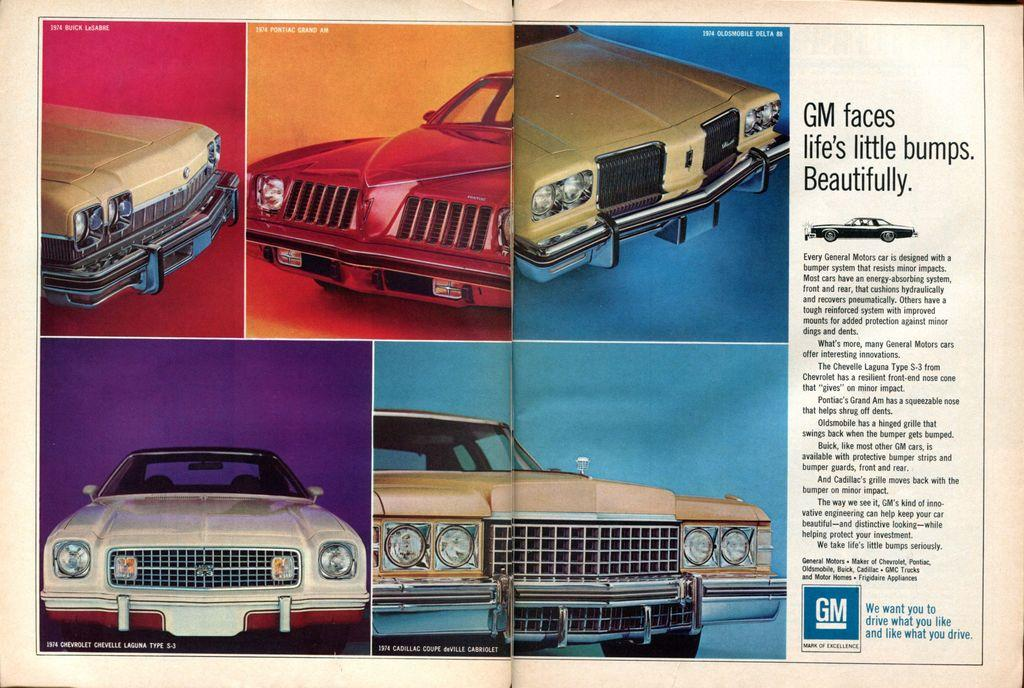What is the main subject of the image? The main subject of the image is an article. What type of images are included in the article? The article contains a collage of car images. Is there any text accompanying the images in the article? Yes, there is text in the image that explains the collage. Can you see any waves in the image? There are no waves present in the image; it features an article with a collage of car images and accompanying text. 